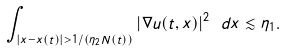Convert formula to latex. <formula><loc_0><loc_0><loc_500><loc_500>\int _ { | x - x ( t ) | > 1 / ( \eta _ { 2 } N ( t ) ) } | \nabla u ( t , x ) | ^ { 2 } \ d x \lesssim \eta _ { 1 } .</formula> 